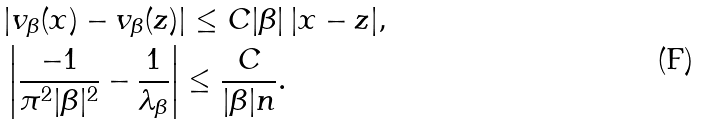Convert formula to latex. <formula><loc_0><loc_0><loc_500><loc_500>& | v _ { \beta } ( x ) - v _ { \beta } ( z ) | \leq C | \beta | \, | x - z | , \\ & \left | \frac { - 1 } { \pi ^ { 2 } | \beta | ^ { 2 } } - \frac { 1 } { \lambda _ { \beta } } \right | \leq \frac { C } { | \beta | n } .</formula> 